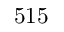Convert formula to latex. <formula><loc_0><loc_0><loc_500><loc_500>5 1 5</formula> 